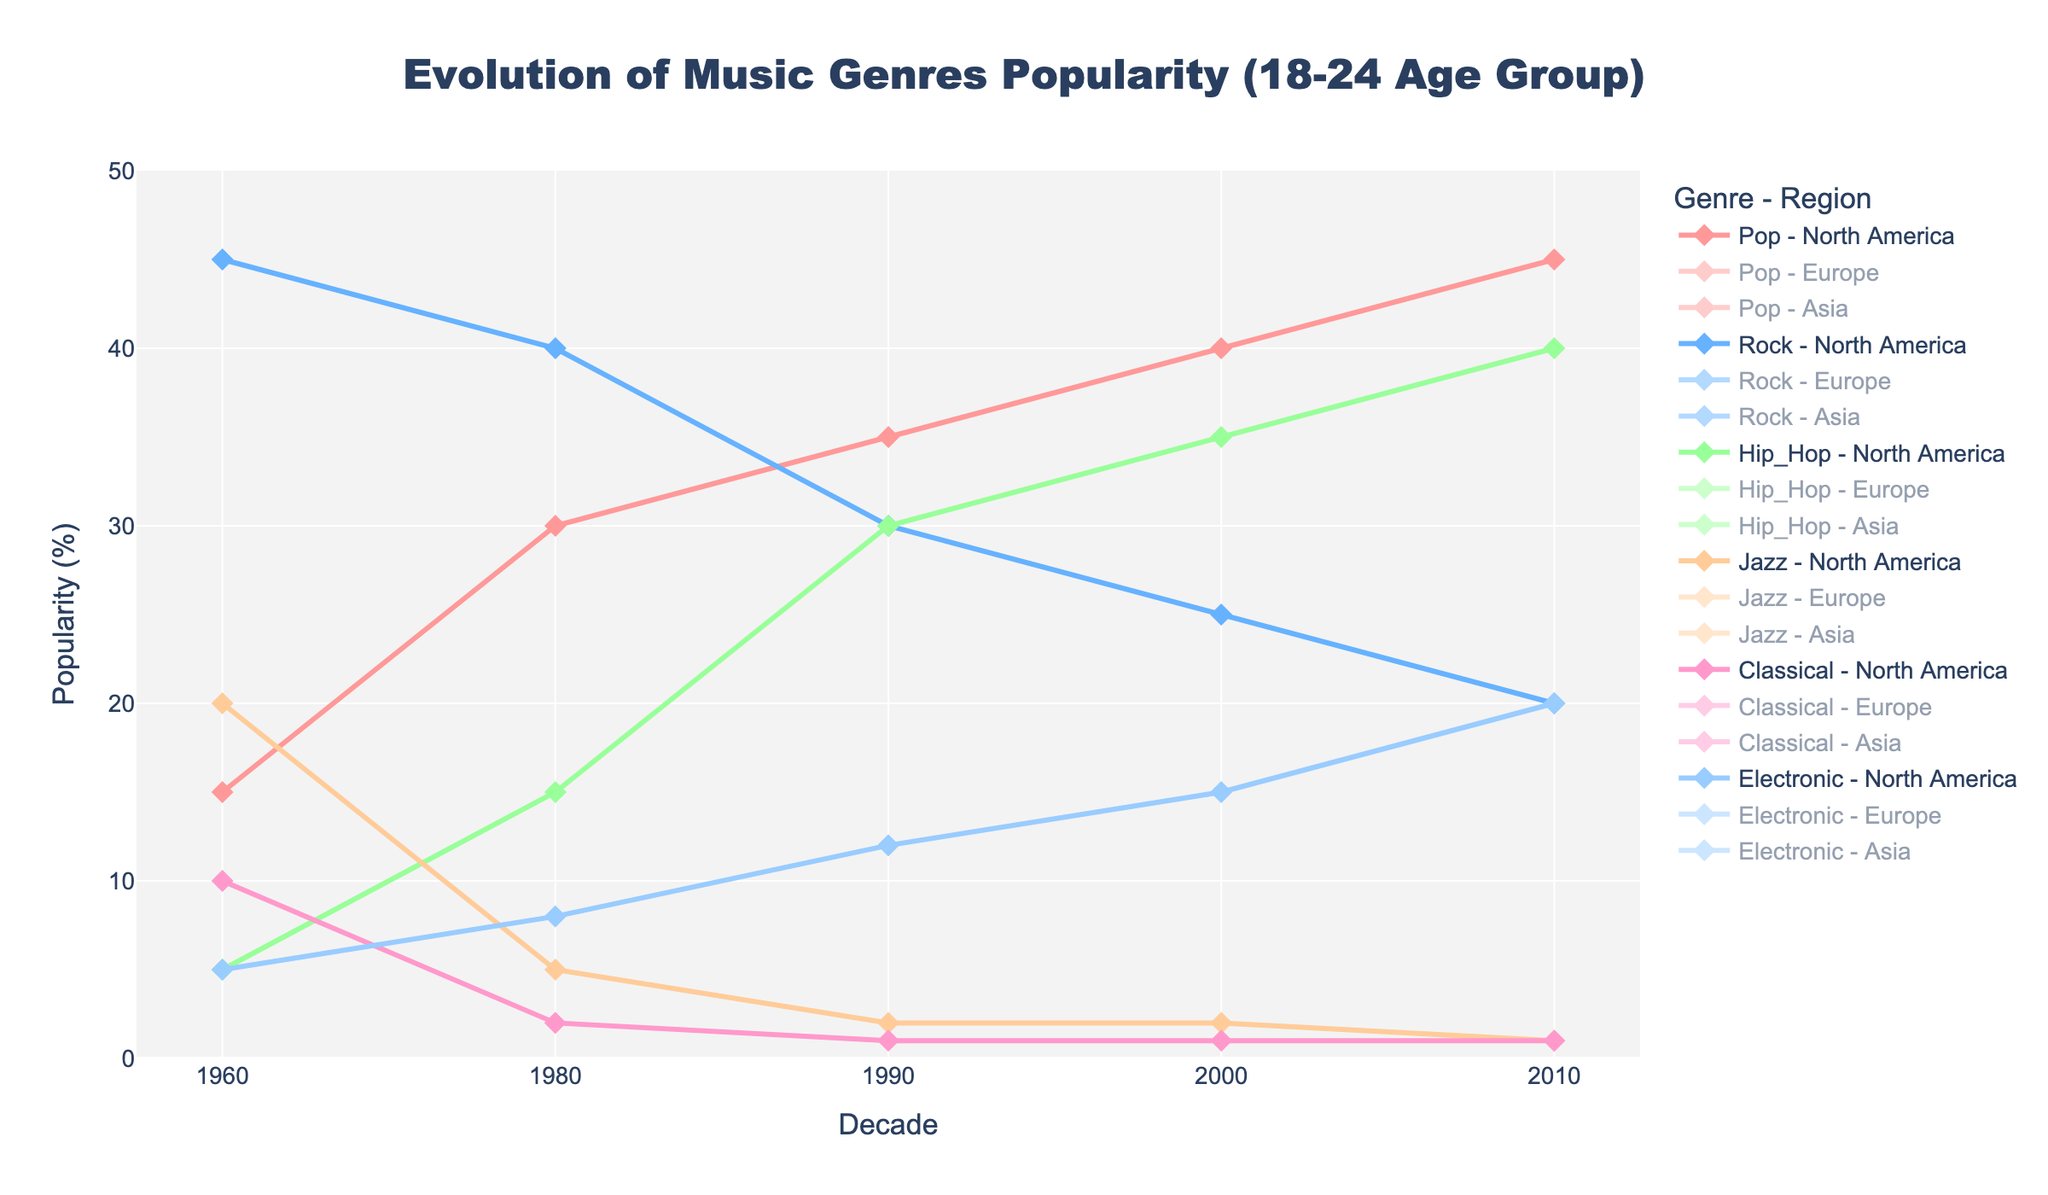What is the title of the figure? The title of the figure is located at the top and specifies the main subject of the plot. By reading the text at the top, the title is "Evolution of Music Genres Popularity (18-24 Age Group)."
Answer: Evolution of Music Genres Popularity (18-24 Age Group) How many decades are represented in the time series plot? The x-axis represents the decades. By counting the unique values along the x-axis, we can see that the decades represented are 1960, 1970, 1980, 1990, 2000, and 2010. Hence, it covers 6 decades.
Answer: 6 Which music genre had the highest popularity in North America in the 1960s for the 18-24 age group? By checking North America's marker in the 1960s under the 18-24 age group and comparing the different genres' popularity, Rock has the highest popularity at 45%.
Answer: Rock Between Pop and Electronic music, which genre saw the highest increase in popularity in North America between the 1990s and 2000s for the 18-24 age group? First, note the values in the 1990s and 2000s for Pop (35% and 40%) and Electronic (12% and 15%). The increase for Pop is 40-35=5, and for Electronic, it is 15-12=3. Pop saw the highest increase.
Answer: Pop In the 2010s, which region had the highest popularity for Hip-Hop music for the 18-24 age group? By scanning the markers under the 2010s for Hip-Hop across all regions, North America has the highest value at 40%.
Answer: North America What is the average popularity of Jazz music in Europe across all decades for the 18-24 age group? Identify the Jazz values for Europe in each decade: 1960 (30), 1970 (18), 1980 (10), 1990 (3), 2000 (2), 2010 (1). Sum these values (30 + 18 + 10 + 3 + 2 + 1 = 64). Divide by the number of decades (6), giving an average of 64/6 ≈ 10.67.
Answer: 10.67 Compare the popularity trend of Classical music between North America and Asia for the 18-24 age group. Which region shows a greater decline from the 1960s to the 2010s? North America's values are 10 (1960) and 1 (2010), showing a decline of 10-1=9. Asia's values are 7 (1960) and 3 (2010), showing a decline of 7-3=4. The greater decline is in North America.
Answer: North America Which genre shows the most consistent popularity in Asia for the 18-24 age group across all decades? By reviewing the data points for each genre in Asia across the decades, Electronic shows relatively consistent values: 1 (1960), 1 (1970), 5 (1980), 10 (1990), 12 (2000), 20 (2010). Despite small changes, it has a consistently increasing trend.
Answer: Electronic How did the popularity of Rock music in Europe for the 18-24 age group change from the 1970s to the 1980s? In Europe, the Rock popularity for the 18-24 age group was 45% in the 1970s and 35% in the 1980s. The change is 35-45 = -10%, indicating a decline.
Answer: Declined by 10% Which decade shows the peak popularity for Pop music in North America for the 18-24 age group? By checking the Pop values in North America for each decade, the highest value is 45% in the 2010s.
Answer: 2010s 